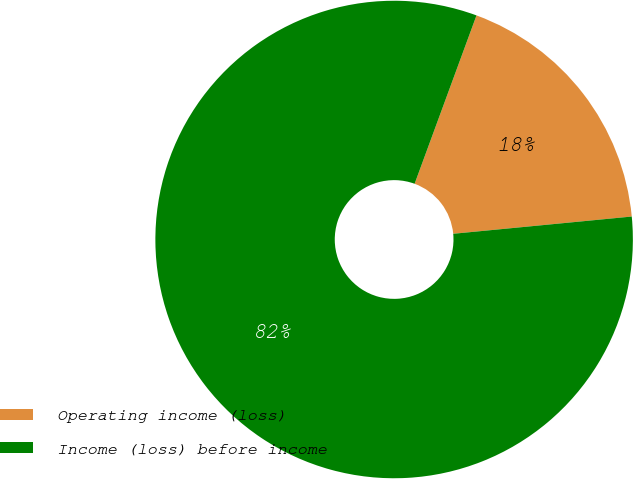<chart> <loc_0><loc_0><loc_500><loc_500><pie_chart><fcel>Operating income (loss)<fcel>Income (loss) before income<nl><fcel>17.86%<fcel>82.14%<nl></chart> 